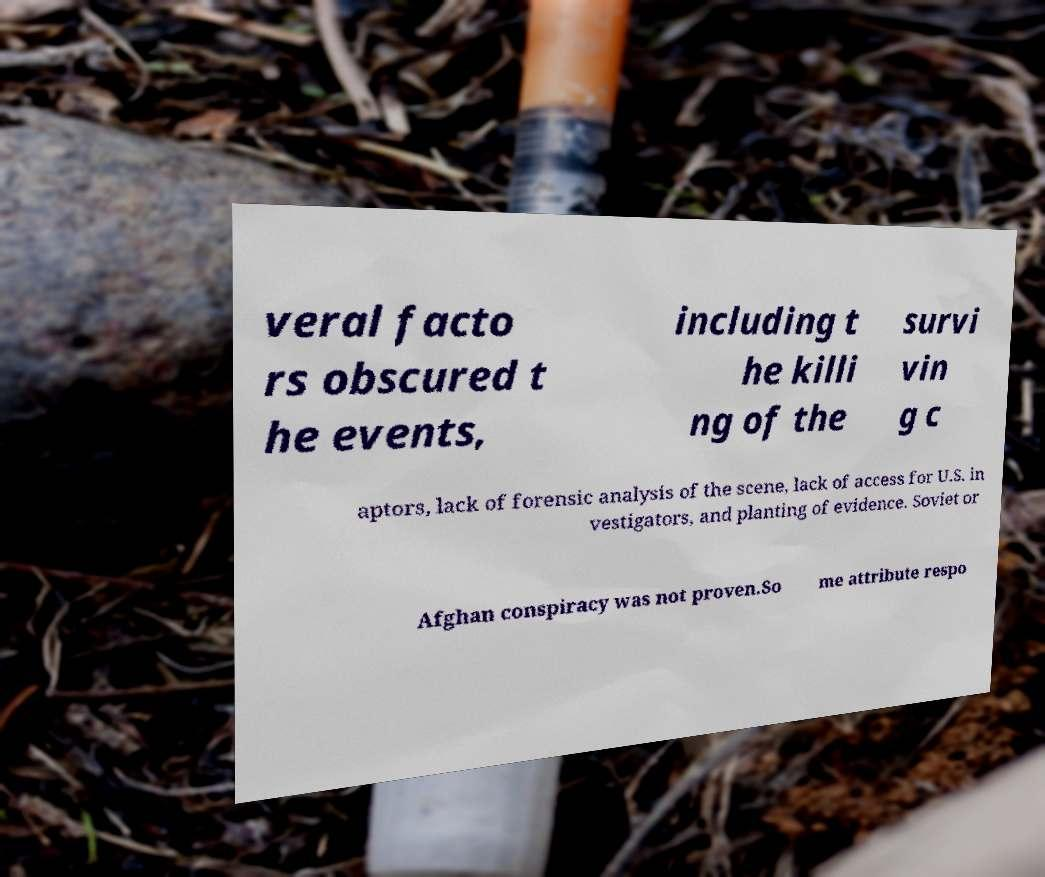I need the written content from this picture converted into text. Can you do that? veral facto rs obscured t he events, including t he killi ng of the survi vin g c aptors, lack of forensic analysis of the scene, lack of access for U.S. in vestigators, and planting of evidence. Soviet or Afghan conspiracy was not proven.So me attribute respo 